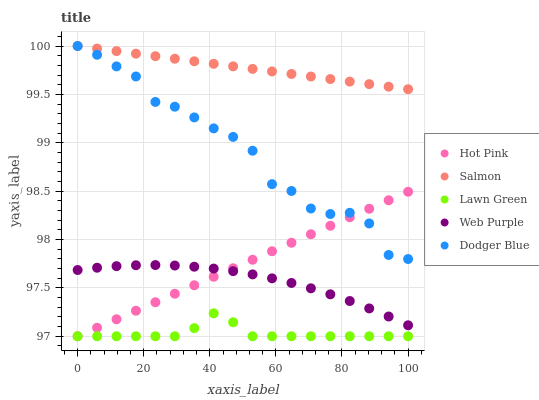Does Lawn Green have the minimum area under the curve?
Answer yes or no. Yes. Does Salmon have the maximum area under the curve?
Answer yes or no. Yes. Does Web Purple have the minimum area under the curve?
Answer yes or no. No. Does Web Purple have the maximum area under the curve?
Answer yes or no. No. Is Salmon the smoothest?
Answer yes or no. Yes. Is Dodger Blue the roughest?
Answer yes or no. Yes. Is Web Purple the smoothest?
Answer yes or no. No. Is Web Purple the roughest?
Answer yes or no. No. Does Lawn Green have the lowest value?
Answer yes or no. Yes. Does Web Purple have the lowest value?
Answer yes or no. No. Does Dodger Blue have the highest value?
Answer yes or no. Yes. Does Web Purple have the highest value?
Answer yes or no. No. Is Lawn Green less than Web Purple?
Answer yes or no. Yes. Is Salmon greater than Lawn Green?
Answer yes or no. Yes. Does Salmon intersect Dodger Blue?
Answer yes or no. Yes. Is Salmon less than Dodger Blue?
Answer yes or no. No. Is Salmon greater than Dodger Blue?
Answer yes or no. No. Does Lawn Green intersect Web Purple?
Answer yes or no. No. 